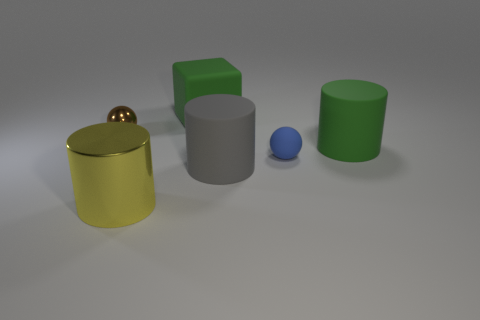The big matte object behind the green matte cylinder is what color?
Your answer should be very brief. Green. Are there the same number of blue things that are left of the gray object and small blue balls?
Provide a short and direct response. No. There is a large thing that is both behind the big gray rubber cylinder and to the right of the green matte cube; what is its shape?
Ensure brevity in your answer.  Cylinder. There is another small thing that is the same shape as the tiny blue rubber thing; what color is it?
Keep it short and to the point. Brown. Are there any other things that are the same color as the cube?
Provide a short and direct response. Yes. There is a tiny thing that is behind the tiny sphere right of the tiny object on the left side of the green matte cube; what shape is it?
Ensure brevity in your answer.  Sphere. Does the green thing that is in front of the large green rubber block have the same size as the thing that is behind the brown object?
Ensure brevity in your answer.  Yes. What number of blue spheres are the same material as the big gray cylinder?
Offer a terse response. 1. What number of brown shiny balls are to the left of the green thing that is right of the small rubber thing in front of the small shiny sphere?
Make the answer very short. 1. Is the shape of the gray matte object the same as the brown thing?
Provide a short and direct response. No. 